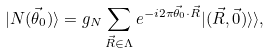<formula> <loc_0><loc_0><loc_500><loc_500>| N ( \vec { \theta } _ { 0 } ) \rangle = g _ { N } \sum _ { \vec { R } \in \Lambda } e ^ { - i 2 \pi \vec { \theta } _ { 0 } \cdot \vec { R } } | ( \vec { R } , \vec { 0 } ) \rangle \rangle ,</formula> 